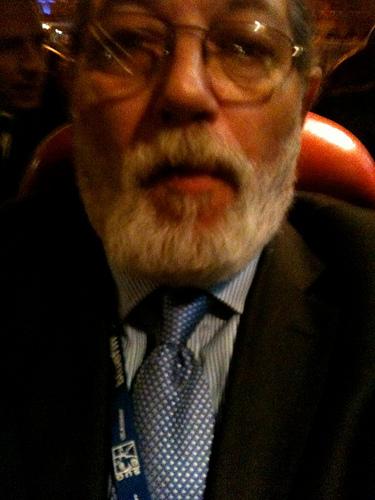Is this man wearing glasses?
Write a very short answer. Yes. Does this man have facial hair?
Keep it brief. Yes. Is this photo in focus?
Give a very brief answer. No. 